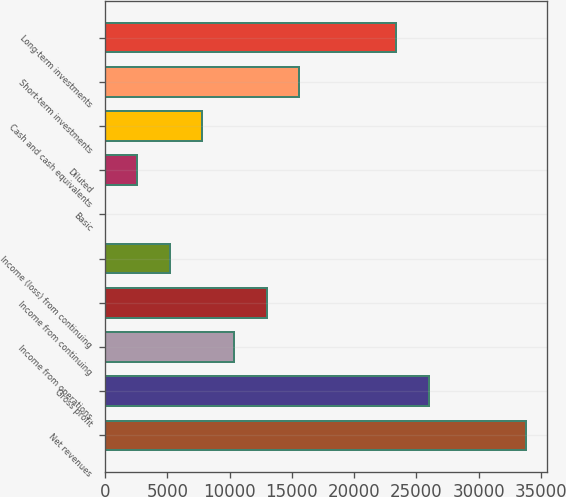Convert chart. <chart><loc_0><loc_0><loc_500><loc_500><bar_chart><fcel>Net revenues<fcel>Gross profit<fcel>Income from operations<fcel>Income from continuing<fcel>Income (loss) from continuing<fcel>Basic<fcel>Diluted<fcel>Cash and cash equivalents<fcel>Short-term investments<fcel>Long-term investments<nl><fcel>33775<fcel>25981<fcel>10393<fcel>12991<fcel>5196.95<fcel>0.95<fcel>2598.95<fcel>7794.95<fcel>15589<fcel>23383<nl></chart> 